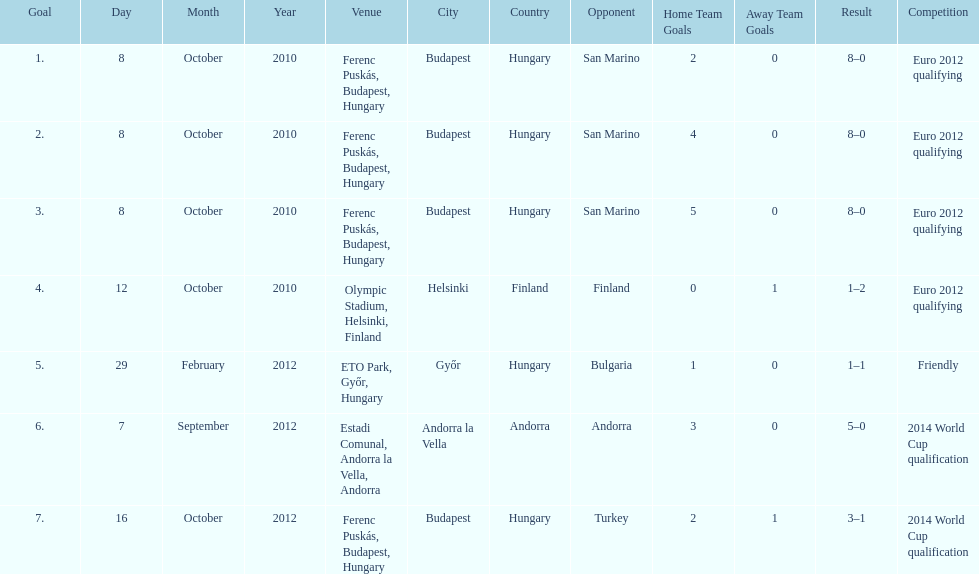How many goals were scored at the euro 2012 qualifying competition? 12. 